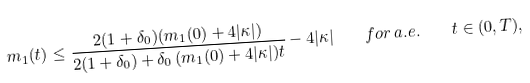Convert formula to latex. <formula><loc_0><loc_0><loc_500><loc_500>m _ { 1 } ( t ) \leq \frac { 2 ( 1 + \delta _ { 0 } ) ( m _ { 1 } ( 0 ) + 4 | \kappa | ) } { 2 ( 1 + \delta _ { 0 } ) + \delta _ { 0 } \, ( m _ { 1 } ( 0 ) + 4 | \kappa | ) t } - 4 | \kappa | \quad f o r \, a . e . \quad t \in ( 0 , T ) ,</formula> 